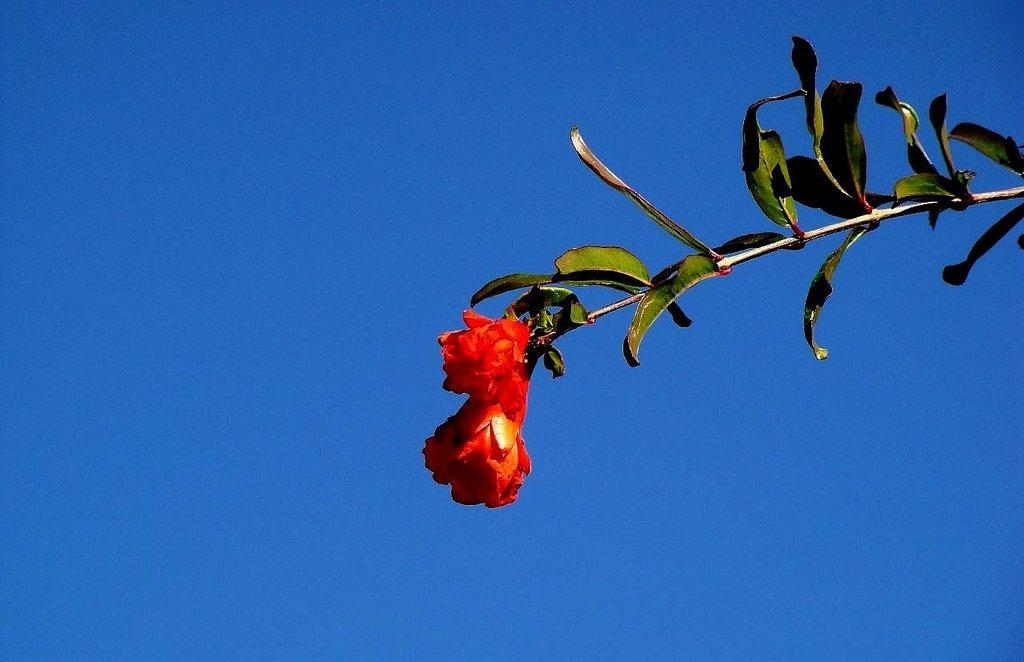What type of flower can be seen in the image? There is a red color flower on a branch in the image. What else can be seen on the right side of the image? There are many leaves on the right side of the image. What is visible in the background of the image? The sky is visible in the background of the image. What type of noise can be heard coming from the flower in the image? There is no noise coming from the flower in the image, as flowers do not produce sound. 